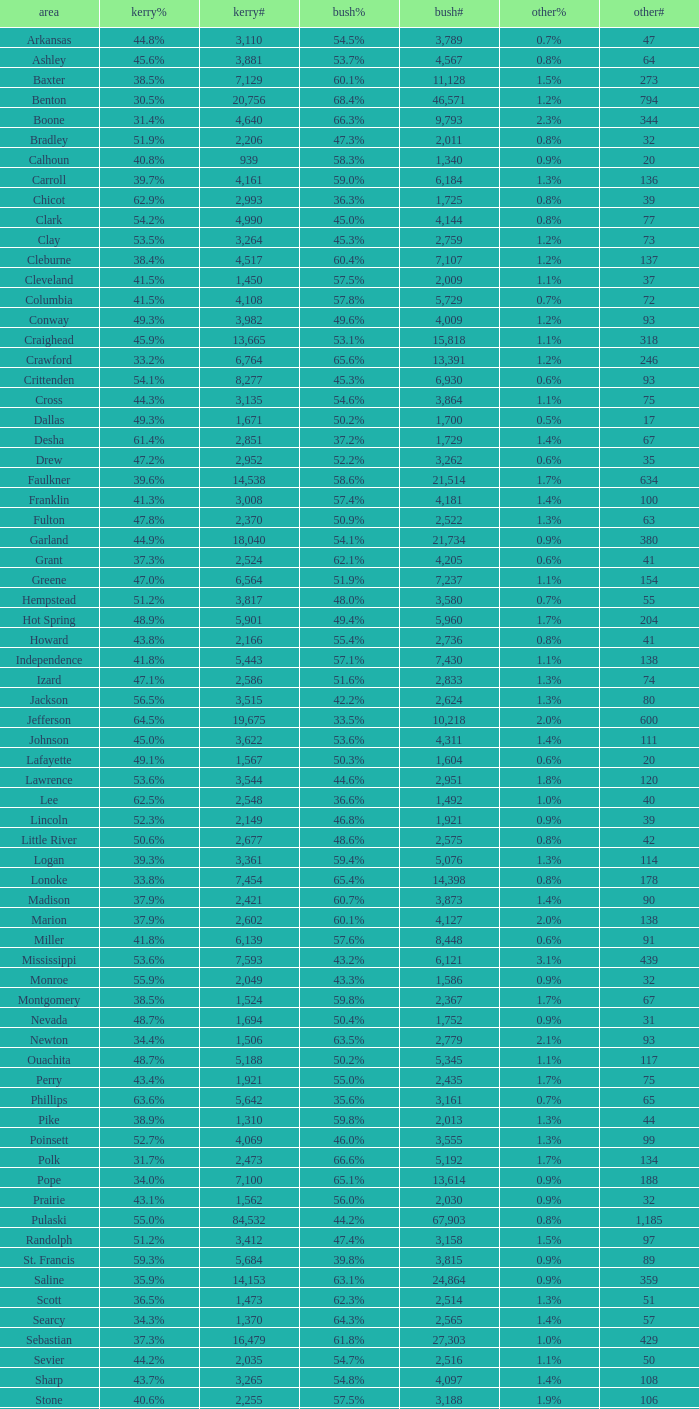When the others percentage is "1.7%", others number is under 75, and kerry number is over 1,524, what is the greatest bush number? None. 